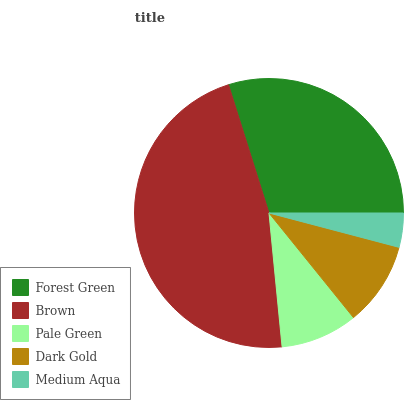Is Medium Aqua the minimum?
Answer yes or no. Yes. Is Brown the maximum?
Answer yes or no. Yes. Is Pale Green the minimum?
Answer yes or no. No. Is Pale Green the maximum?
Answer yes or no. No. Is Brown greater than Pale Green?
Answer yes or no. Yes. Is Pale Green less than Brown?
Answer yes or no. Yes. Is Pale Green greater than Brown?
Answer yes or no. No. Is Brown less than Pale Green?
Answer yes or no. No. Is Dark Gold the high median?
Answer yes or no. Yes. Is Dark Gold the low median?
Answer yes or no. Yes. Is Pale Green the high median?
Answer yes or no. No. Is Forest Green the low median?
Answer yes or no. No. 